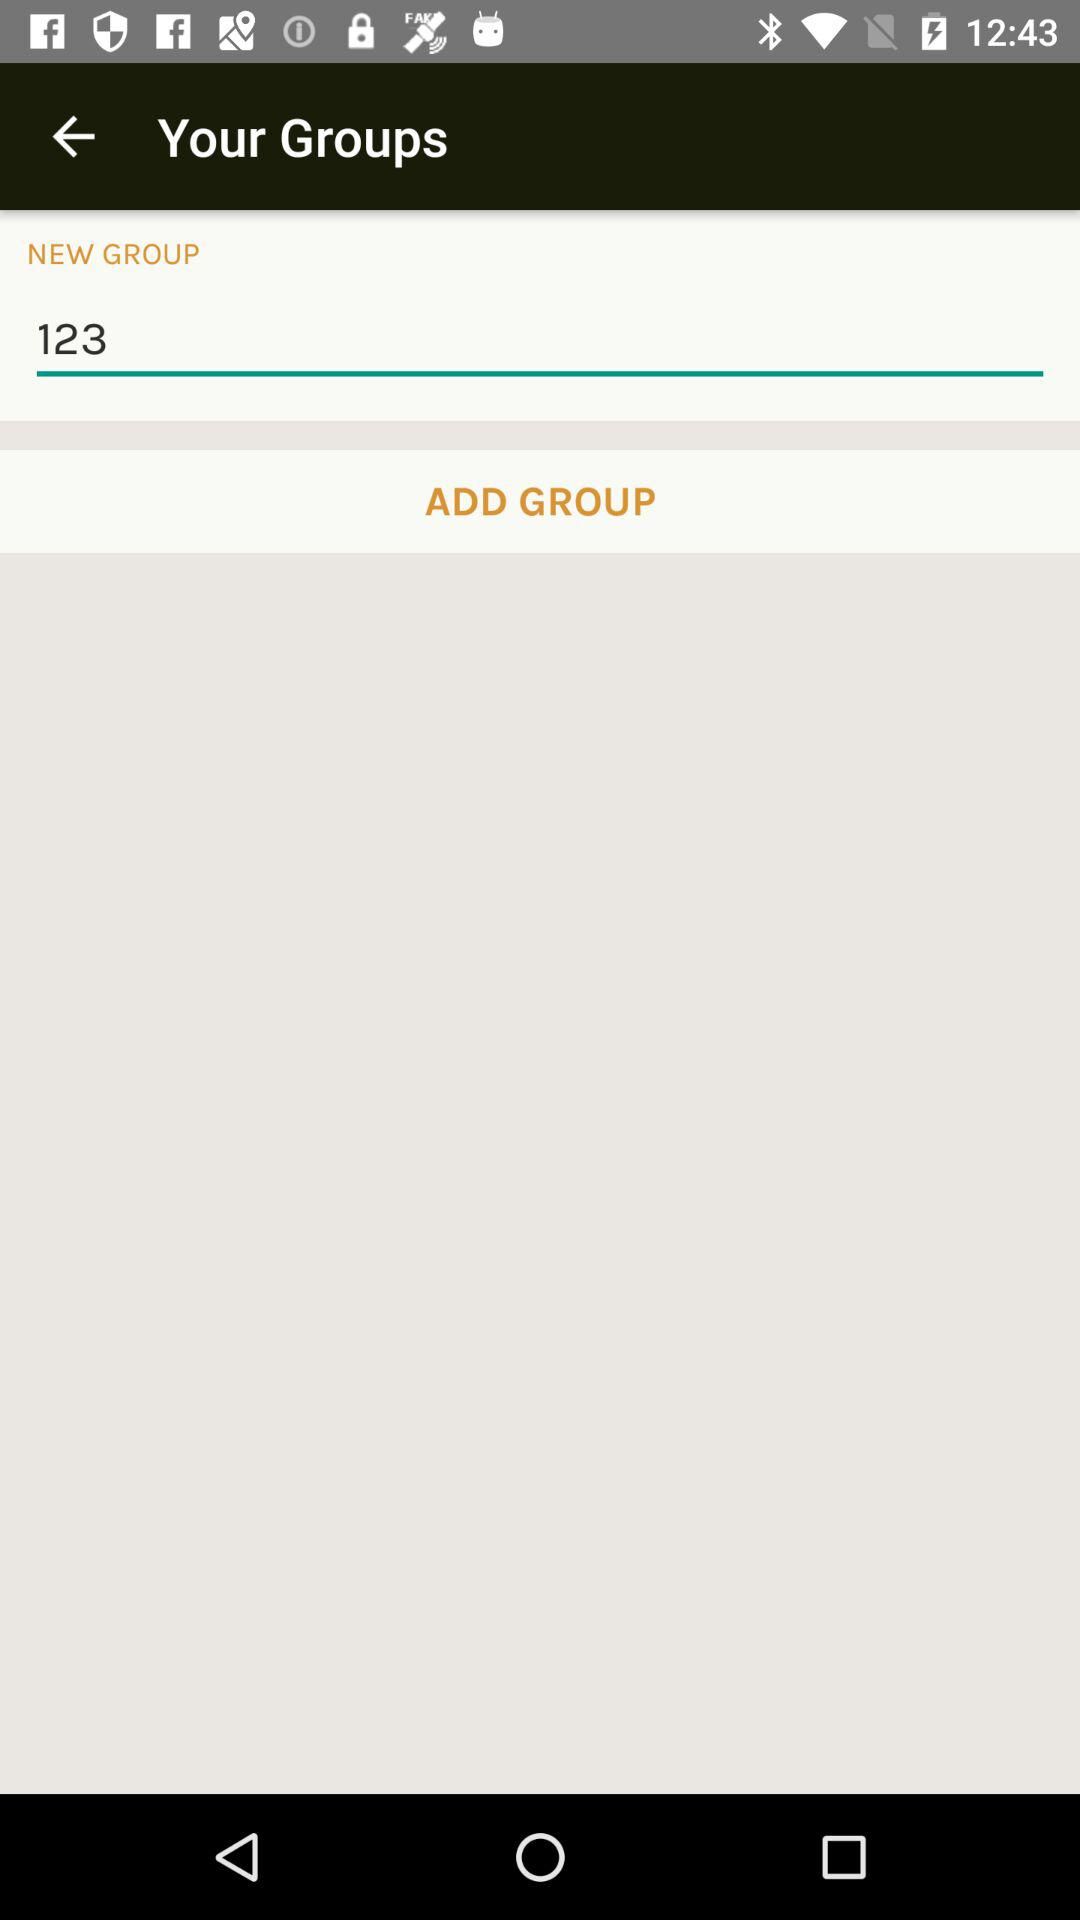What number is typed in the new group? The typed number is 123. 